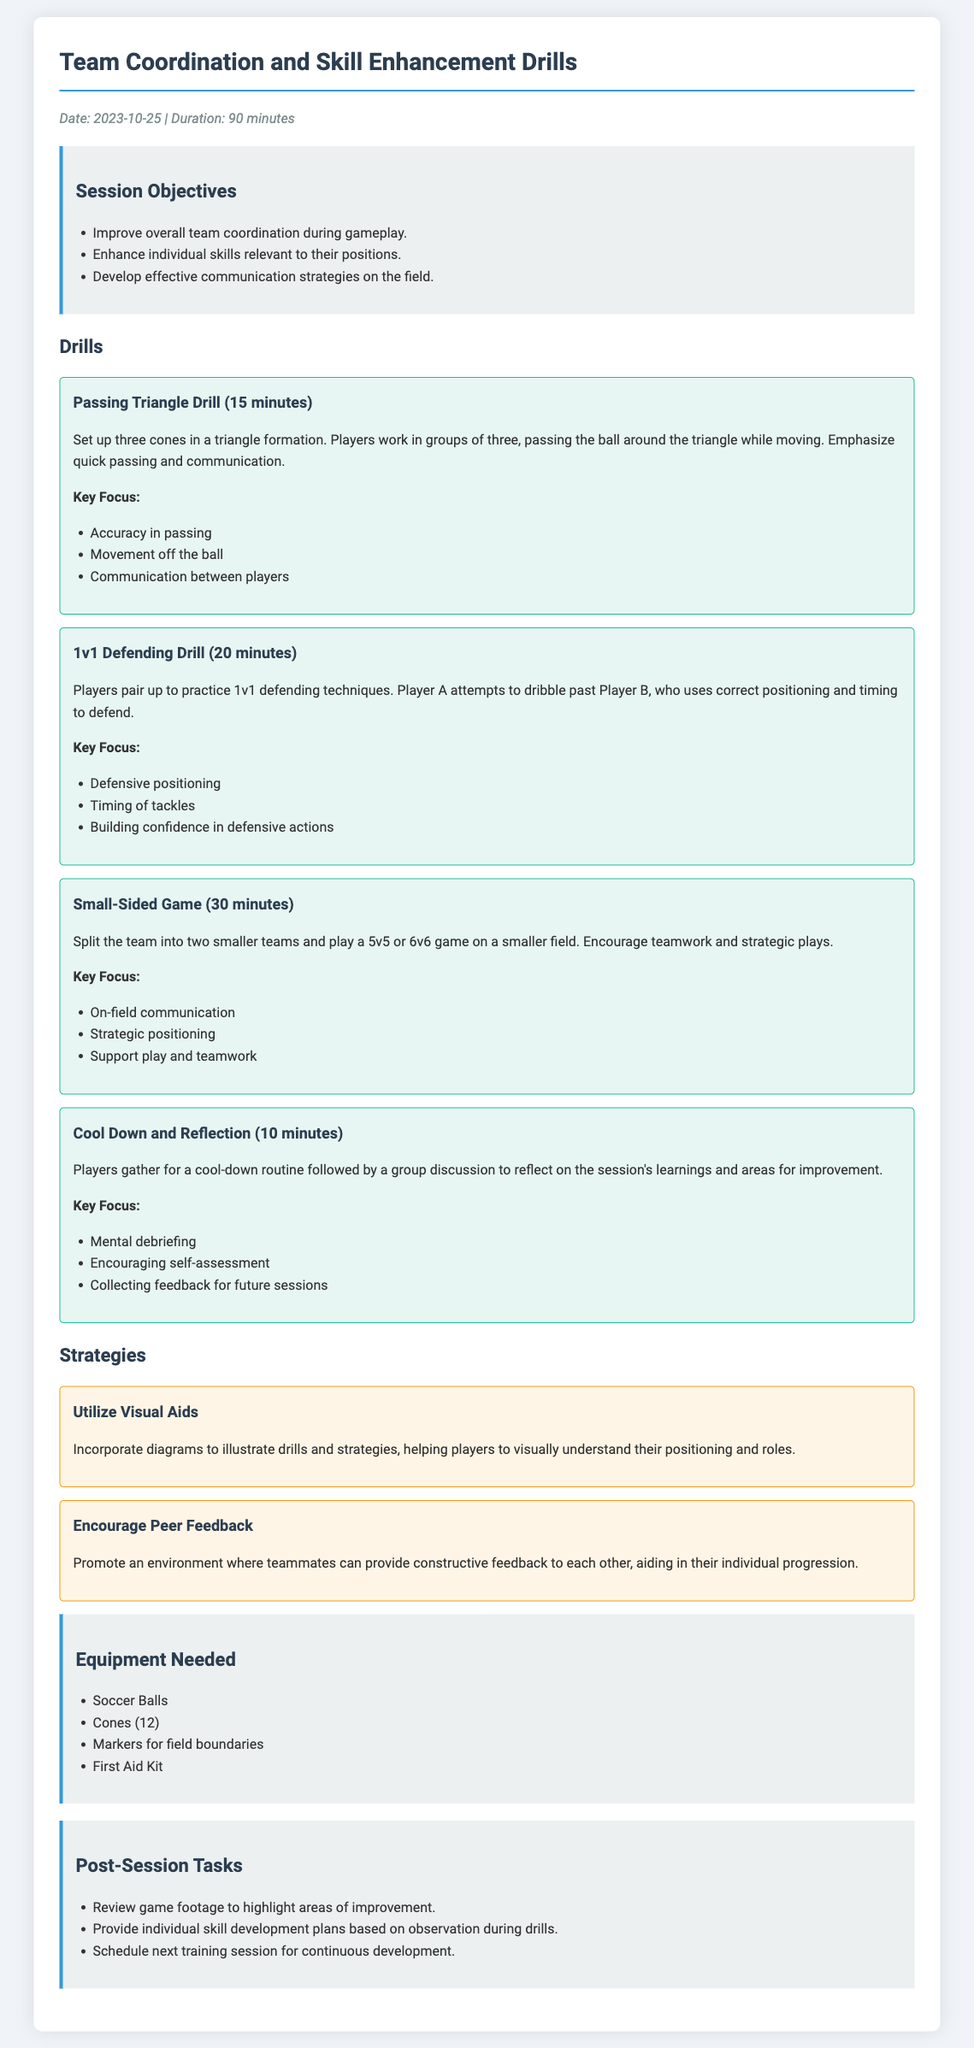what is the date of the training session? The date is specified at the top of the document under the meta section as the date of the session.
Answer: 2023-10-25 what is the duration of the session? The duration is noted in the meta section of the document, indicating how long the session will last.
Answer: 90 minutes how many minutes is allocated for the Passing Triangle Drill? This drill's time allocation is specified in its title and description section.
Answer: 15 minutes what key focus is emphasized in the Small-Sided Game? The key focus is highlighted in the description and relates to teamwork during this drill.
Answer: On-field communication what equipment is needed for the training session? The equipment section lists the necessary items required for the drills in the session.
Answer: Soccer Balls, Cones (12), Markers for field boundaries, First Aid Kit which strategy promotes an environment for teammates to provide feedback? The strategies section mentions specific strategies aimed at improving skills and communication within the team.
Answer: Encourage Peer Feedback what is the last activity in the training session? The last activity is identified in the drills section and signifies a cooldown and reflective component of the session.
Answer: Cool Down and Reflection what are the three session objectives? The objectives are specified in a list format, clarifying what the session aims to achieve.
Answer: Improve overall team coordination during gameplay, Enhance individual skills relevant to their positions, Develop effective communication strategies on the field 